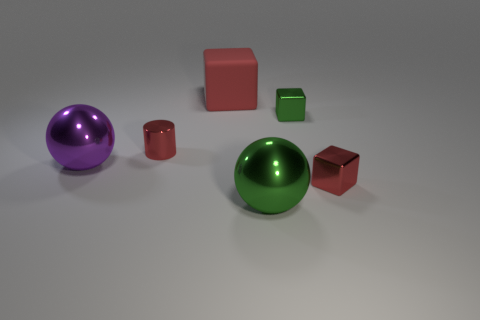Add 4 red metallic things. How many objects exist? 10 Subtract all spheres. How many objects are left? 4 Subtract 1 purple spheres. How many objects are left? 5 Subtract all small red spheres. Subtract all tiny metallic blocks. How many objects are left? 4 Add 5 green metallic blocks. How many green metallic blocks are left? 6 Add 5 green metal objects. How many green metal objects exist? 7 